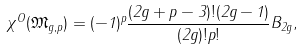Convert formula to latex. <formula><loc_0><loc_0><loc_500><loc_500>\chi ^ { O } ( \mathfrak M _ { g , p } ) = ( - 1 ) ^ { p } \frac { ( 2 g + p - 3 ) ! ( 2 g - 1 ) } { ( 2 g ) ! p ! } B _ { 2 g } ,</formula> 